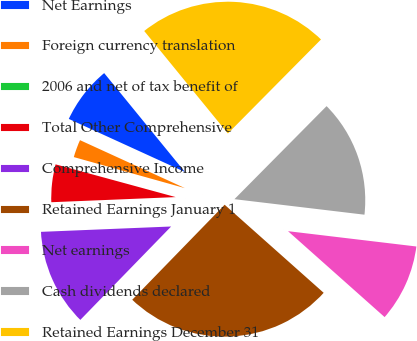<chart> <loc_0><loc_0><loc_500><loc_500><pie_chart><fcel>Net Earnings<fcel>Foreign currency translation<fcel>2006 and net of tax benefit of<fcel>Total Other Comprehensive<fcel>Comprehensive Income<fcel>Retained Earnings January 1<fcel>Net earnings<fcel>Cash dividends declared<fcel>Retained Earnings December 31<nl><fcel>7.28%<fcel>2.49%<fcel>0.1%<fcel>4.89%<fcel>12.07%<fcel>25.71%<fcel>9.68%<fcel>14.47%<fcel>23.32%<nl></chart> 